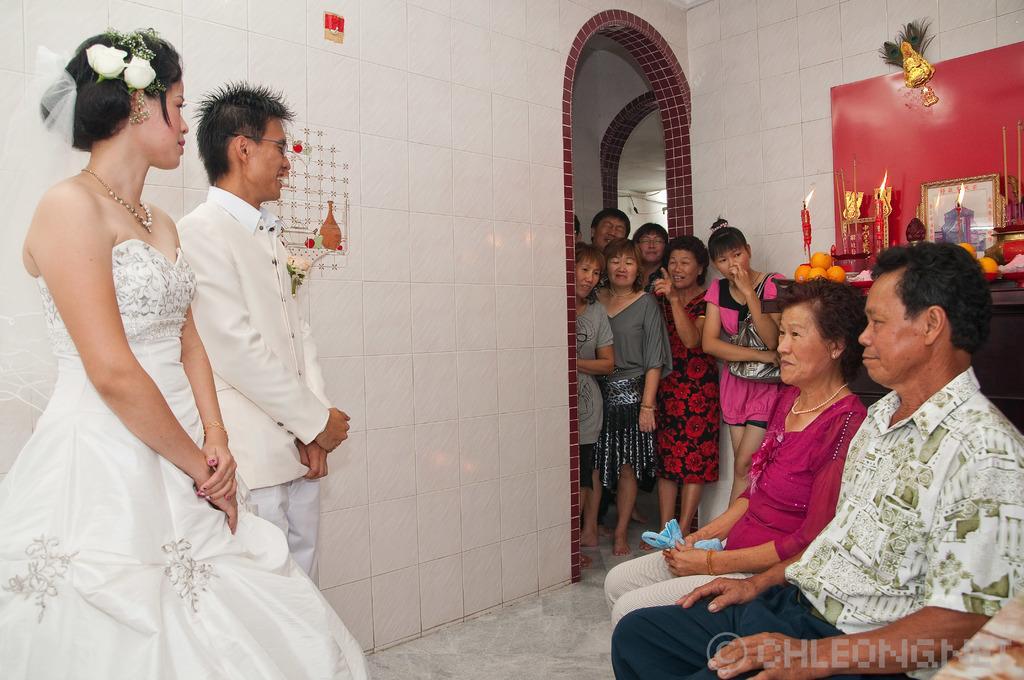In one or two sentences, can you explain what this image depicts? This is an inside view. On the left side a woman and a man are wearing white color dresses and standing on the floor facing towards the right side. On the right side a woman and a man are sitting. At the back of these people there is a table on which fruits, photo frame and some other objects are placed. In the background few people are standing. 